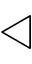Convert formula to latex. <formula><loc_0><loc_0><loc_500><loc_500>\triangleleft</formula> 